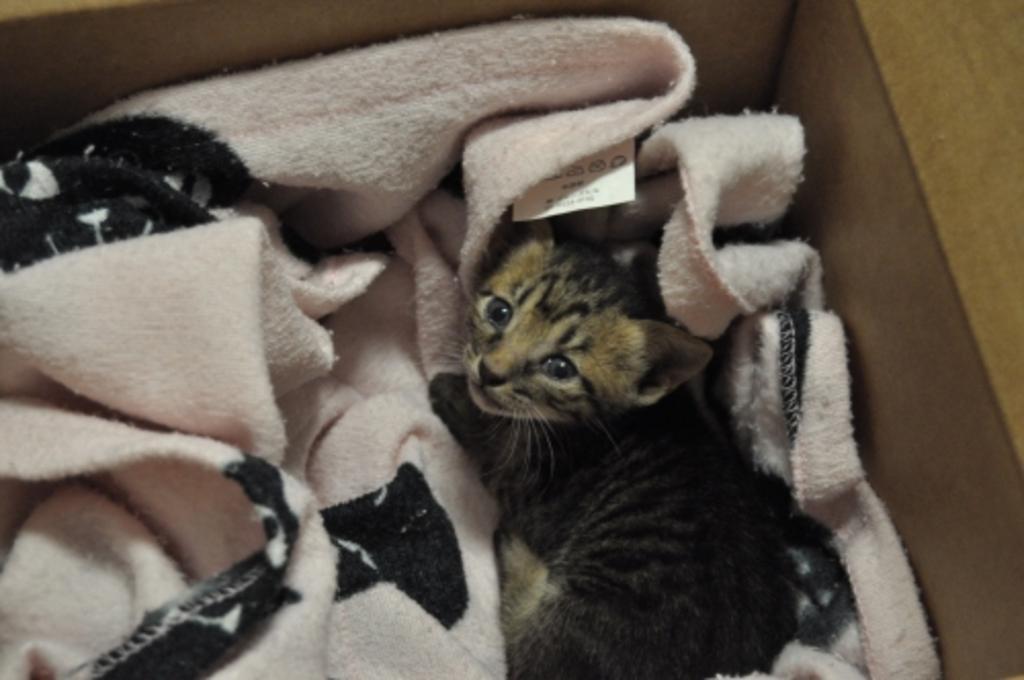Could you give a brief overview of what you see in this image? In this image, we can see a cat and a cloth. 